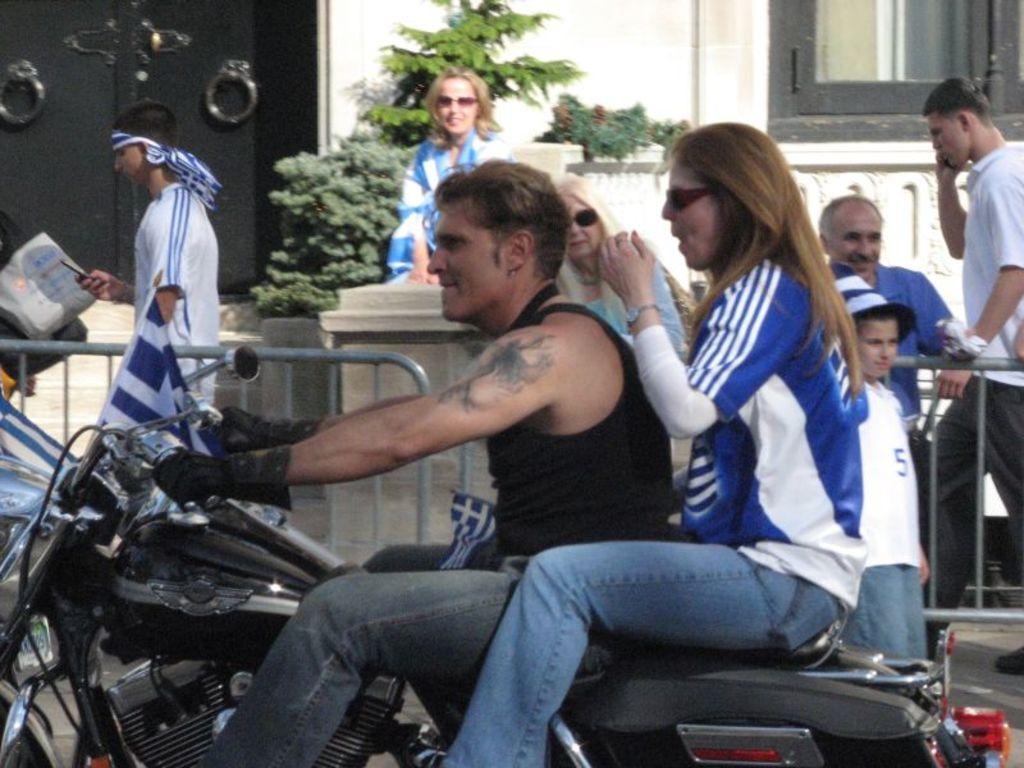Describe this image in one or two sentences. The person wearing black jeans is riding a bike and there is a women behind him and there are group of people beside them. 